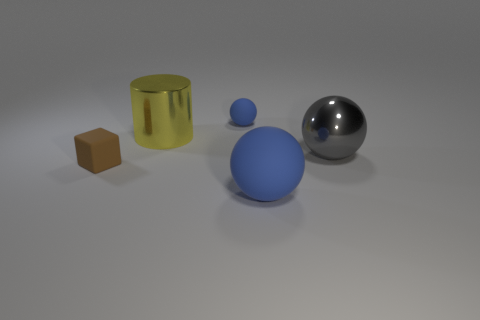Add 4 tiny blue objects. How many objects exist? 9 Subtract all cylinders. How many objects are left? 4 Subtract all matte blocks. Subtract all brown rubber cubes. How many objects are left? 3 Add 4 rubber cubes. How many rubber cubes are left? 5 Add 1 blue rubber objects. How many blue rubber objects exist? 3 Subtract 0 blue cylinders. How many objects are left? 5 